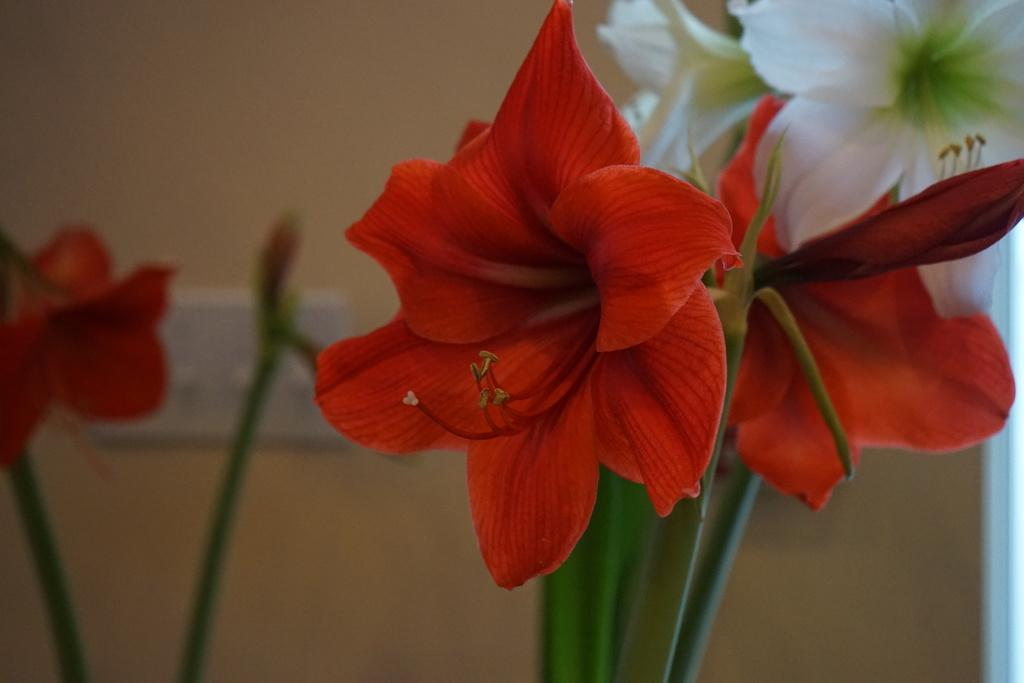What colors are the flowers in the image? The flowers in the image are red and white. Where are the flowers located in the image? The flowers are in the front of the image. What can be seen behind the flowers in the image? There is a wall in the image. What is attached to the wall in the image? A switch board is present on the wall. How many rings can be seen on the flowers in the image? There are no rings visible on the flowers in the image; they are simply red and white flowers. 